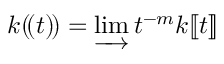Convert formula to latex. <formula><loc_0><loc_0><loc_500><loc_500>k ( \, ( t ) \, ) = \varinjlim t ^ { - m } k [ \, [ t ] \, ]</formula> 